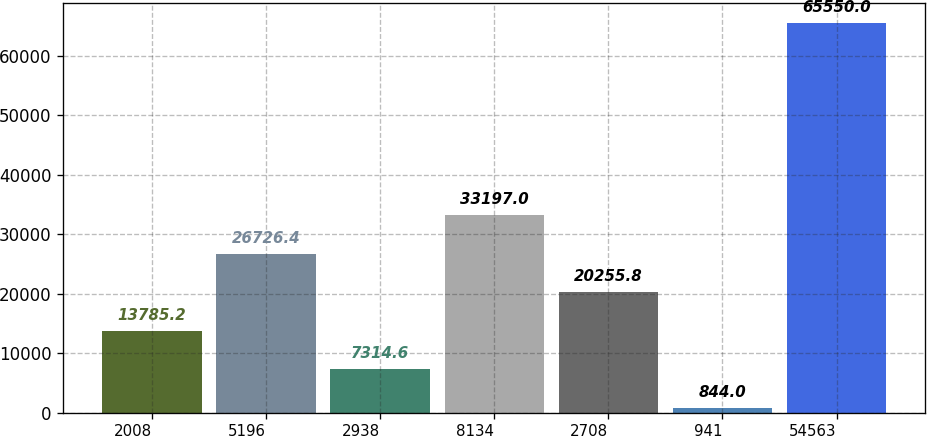Convert chart to OTSL. <chart><loc_0><loc_0><loc_500><loc_500><bar_chart><fcel>2008<fcel>5196<fcel>2938<fcel>8134<fcel>2708<fcel>941<fcel>54563<nl><fcel>13785.2<fcel>26726.4<fcel>7314.6<fcel>33197<fcel>20255.8<fcel>844<fcel>65550<nl></chart> 